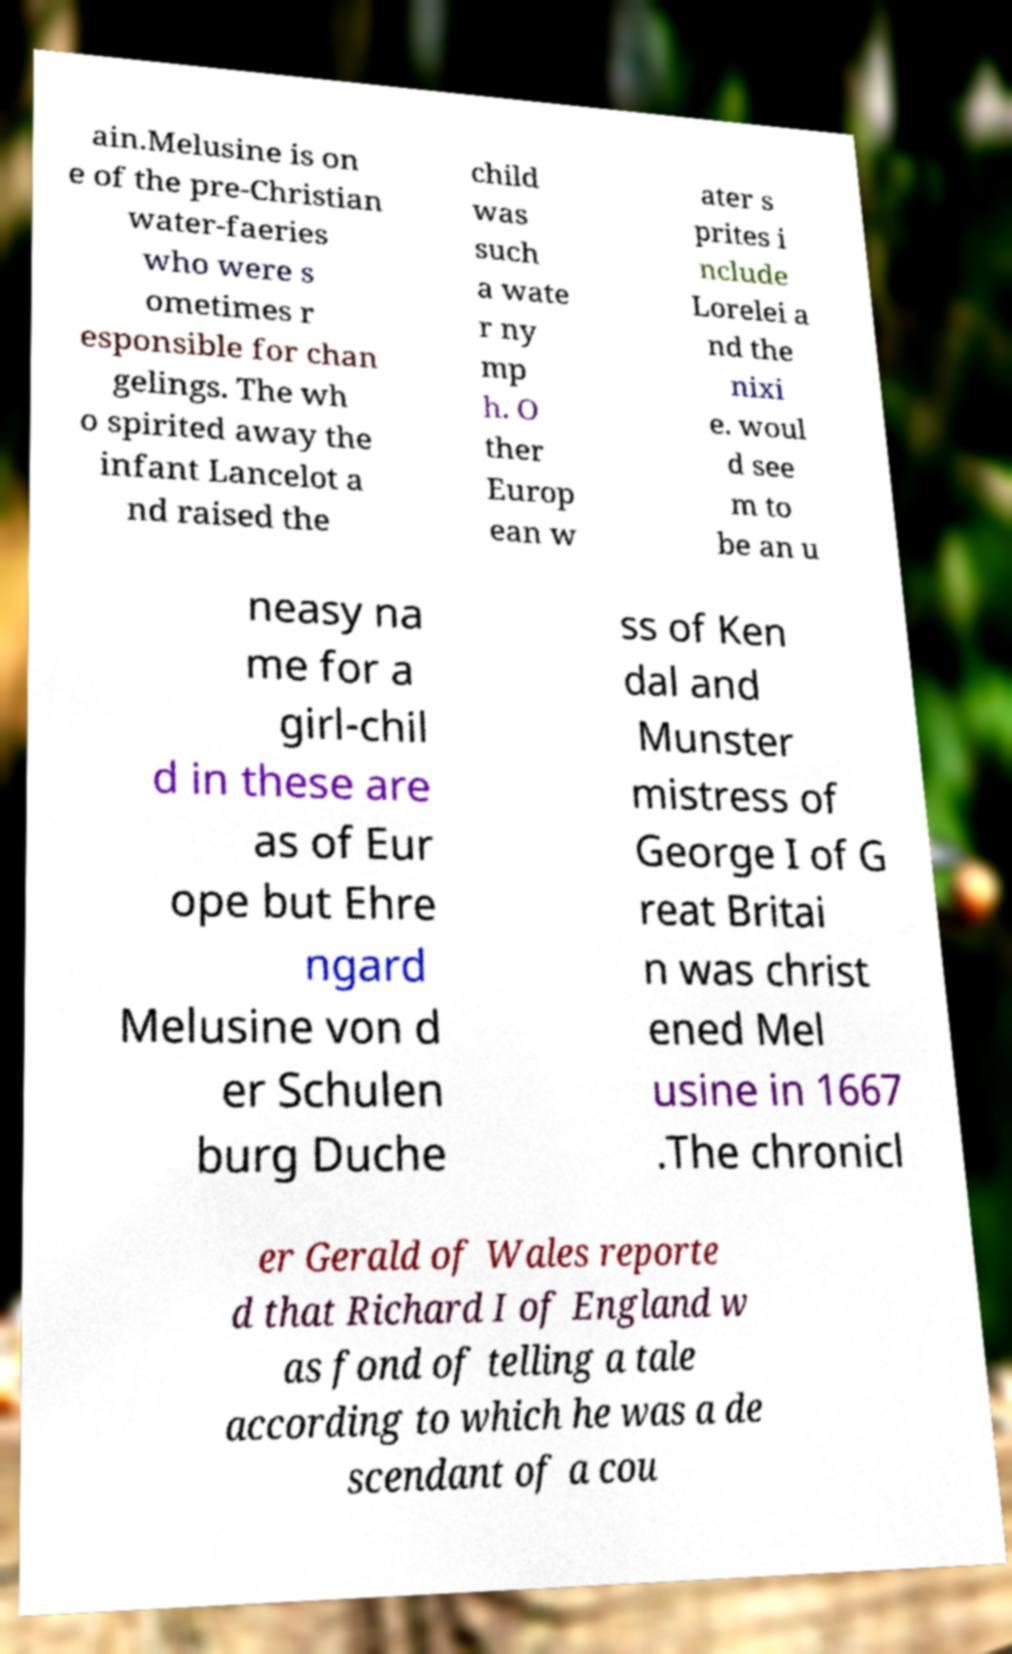For documentation purposes, I need the text within this image transcribed. Could you provide that? ain.Melusine is on e of the pre-Christian water-faeries who were s ometimes r esponsible for chan gelings. The wh o spirited away the infant Lancelot a nd raised the child was such a wate r ny mp h. O ther Europ ean w ater s prites i nclude Lorelei a nd the nixi e. woul d see m to be an u neasy na me for a girl-chil d in these are as of Eur ope but Ehre ngard Melusine von d er Schulen burg Duche ss of Ken dal and Munster mistress of George I of G reat Britai n was christ ened Mel usine in 1667 .The chronicl er Gerald of Wales reporte d that Richard I of England w as fond of telling a tale according to which he was a de scendant of a cou 